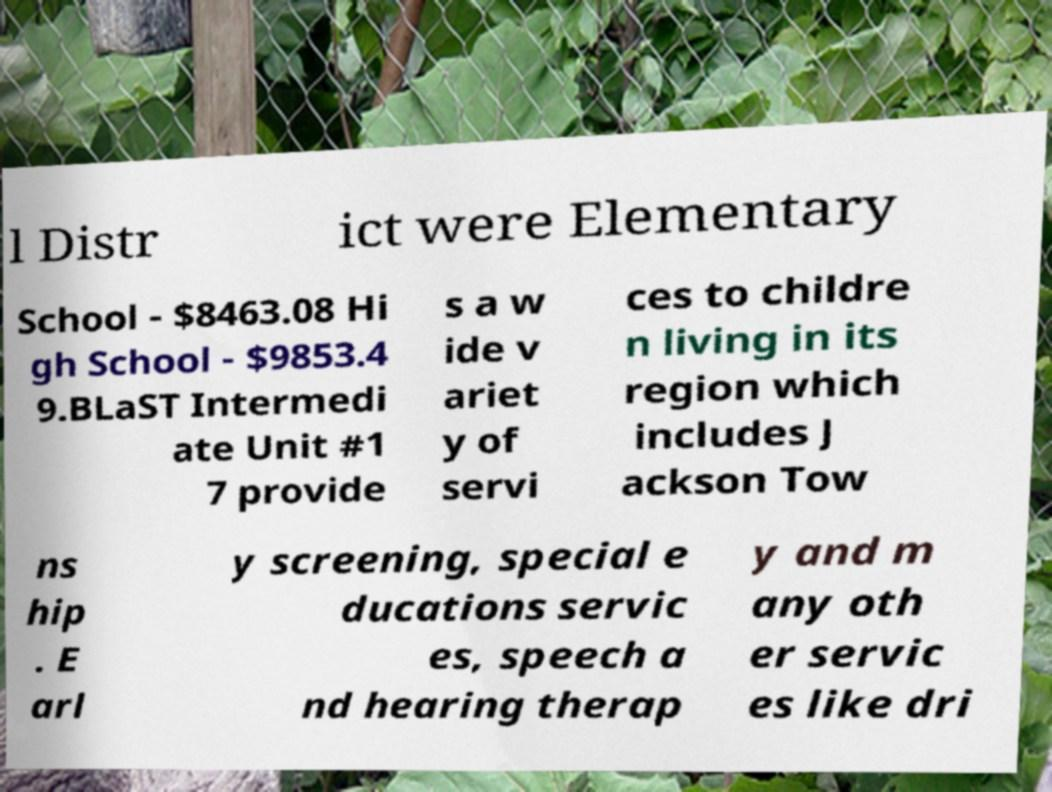Could you assist in decoding the text presented in this image and type it out clearly? l Distr ict were Elementary School - $8463.08 Hi gh School - $9853.4 9.BLaST Intermedi ate Unit #1 7 provide s a w ide v ariet y of servi ces to childre n living in its region which includes J ackson Tow ns hip . E arl y screening, special e ducations servic es, speech a nd hearing therap y and m any oth er servic es like dri 